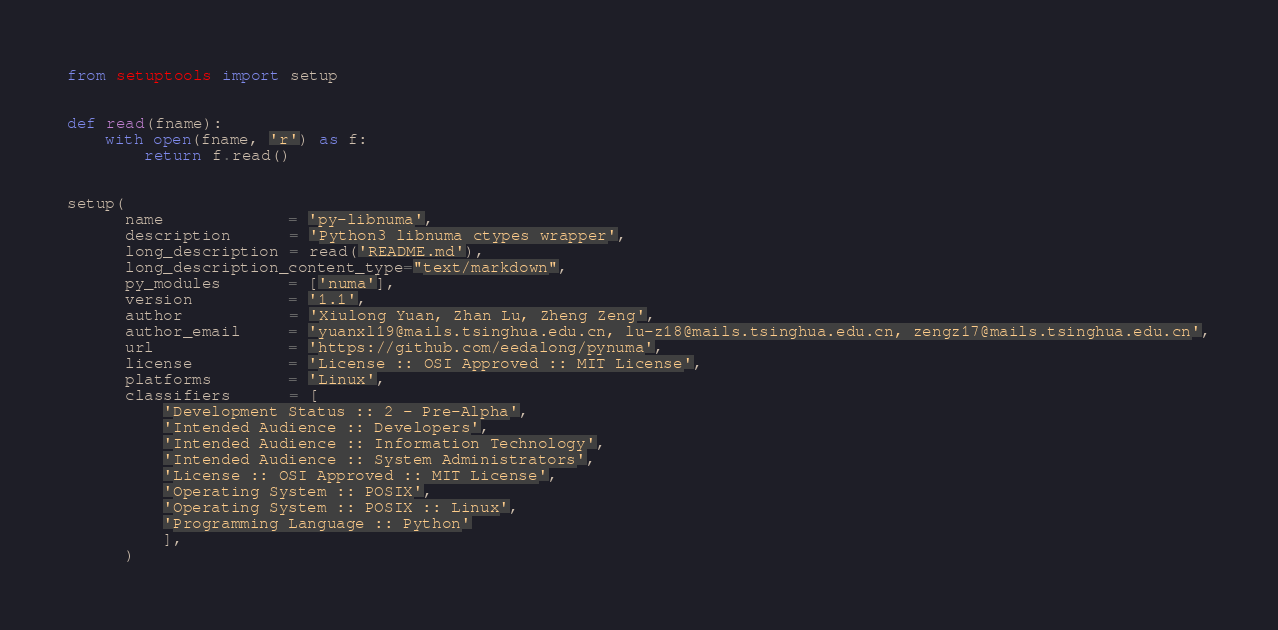Convert code to text. <code><loc_0><loc_0><loc_500><loc_500><_Python_>from setuptools import setup


def read(fname):
    with open(fname, 'r') as f:
        return f.read()


setup(
      name             = 'py-libnuma',
      description      = 'Python3 libnuma ctypes wrapper',
      long_description = read('README.md'),
      long_description_content_type="text/markdown",
      py_modules       = ['numa'],
      version          = '1.1',
      author           = 'Xiulong Yuan, Zhan Lu, Zheng Zeng',
      author_email     = 'yuanxl19@mails.tsinghua.edu.cn, lu-z18@mails.tsinghua.edu.cn, zengz17@mails.tsinghua.edu.cn',
      url              = 'https://github.com/eedalong/pynuma',
      license          = 'License :: OSI Approved :: MIT License',
      platforms        = 'Linux',
      classifiers      = [
          'Development Status :: 2 - Pre-Alpha',
          'Intended Audience :: Developers',
          'Intended Audience :: Information Technology',
          'Intended Audience :: System Administrators',
          'License :: OSI Approved :: MIT License',
          'Operating System :: POSIX',
          'Operating System :: POSIX :: Linux',
          'Programming Language :: Python'
          ],
      )
</code> 